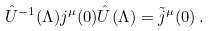Convert formula to latex. <formula><loc_0><loc_0><loc_500><loc_500>\hat { U } ^ { - 1 } ( \Lambda ) j ^ { \mu } ( 0 ) \hat { U } ( \Lambda ) = \tilde { j } ^ { \mu } ( 0 ) \, .</formula> 